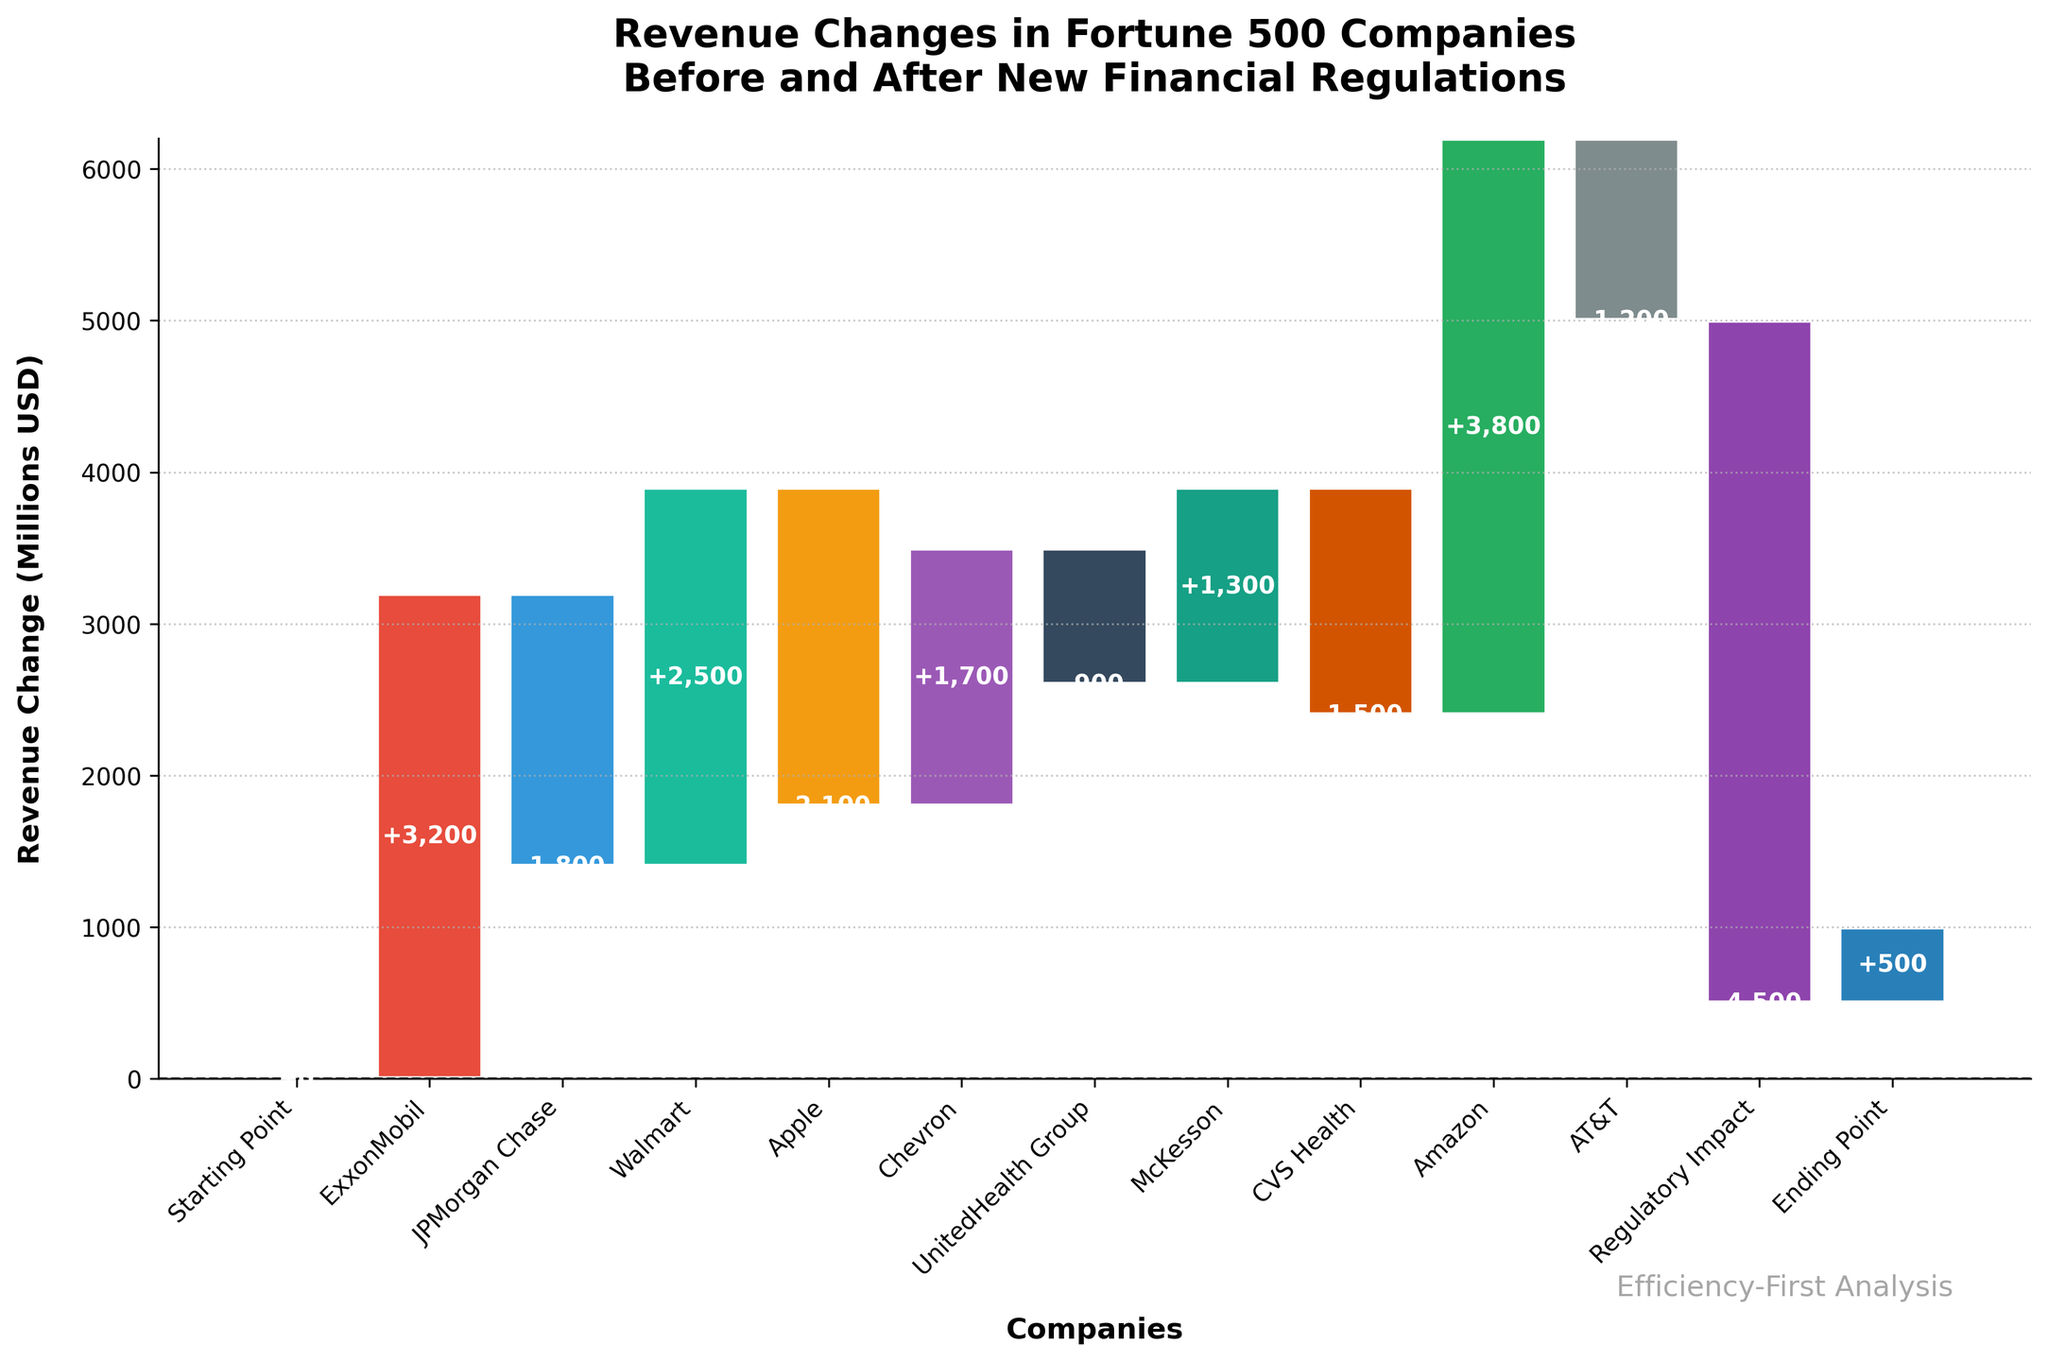What's the total revenue increase of ExxonMobil and Walmart combined? ExxonMobil has a revenue increase of 3200 million USD and Walmart has an increase of 2500 million USD. Adding these together gives 3200 + 2500 = 5700 million USD.
Answer: 5700 million USD What's the overall net change in revenue for all companies shown before accounting for the Regulatory Impact? Sum up the individual revenue changes (+3200 -1800 +2500 -2100 +1700 -900 +1300 -1500 +3800 -1200) = 9000 million USD. The Regulatory Impact (-4500 million USD) is not included here.
Answer: 9000 million USD Which company experienced the highest revenue increase? By comparing the revenue increases, Amazon has the highest increase with +3800 million USD.
Answer: Amazon Which companies experienced a revenue decrease after the implementation of new financial regulations? The companies with negative revenue changes are JPMorgan Chase (-1800 million USD), Apple (-2100 million USD), UnitedHealth Group (-900 million USD), CVS Health (-1500 million USD), and AT&T (-1200 million USD).
Answer: JPMorgan Chase, Apple, UnitedHealth Group, CVS Health, AT&T How does the total negative impact from new regulations compare to the revenue decrease of Apple? The revenue decrease due to new regulations is -4500 million USD, while Apple's decrease is -2100 million USD. The negative regulatory impact is significantly larger.
Answer: The regulatory impact is larger What is the final revenue change after accounting for the Regulatory Impact? The final revenue change is 9000 (total net change before regulations) - 4500 (negative regulatory impact) = 4500 million USD. The 'Ending Point' value, 500 million USD, needs to be rechecked.
Answer: 4500 million USD Which company had a revenue change closest to the impact of the regulations? Compare the absolute values of individual revenue changes with the regulatory impact value of 4500 million USD. Amazon, with +3800 million USD, is the closest.
Answer: Amazon How many companies in the chart have a net positive revenue change? Count the companies with positive revenue changes: ExxonMobil, Walmart, Chevron, McKesson, Amazon. There are 5 companies.
Answer: 5 companies 